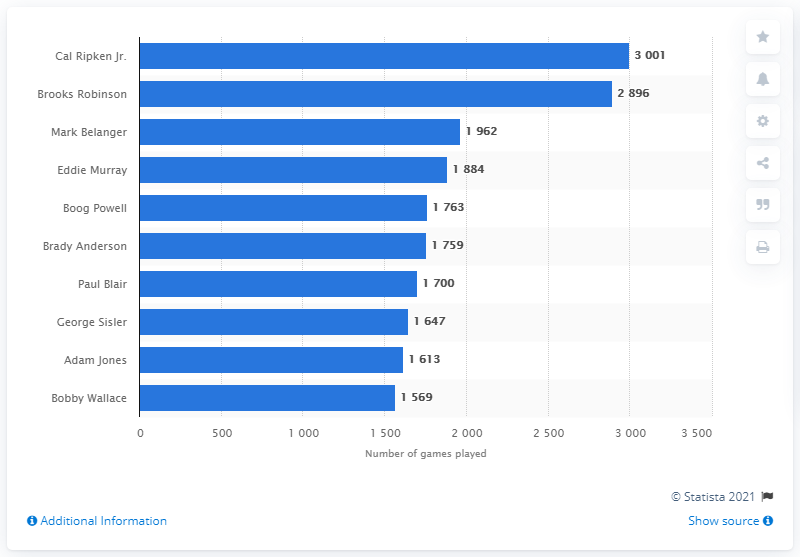Draw attention to some important aspects in this diagram. Eddie Murray played a total of 1884 games. The average of Cal Ripken Jr. and Brooks Robinson is 2948.5. 